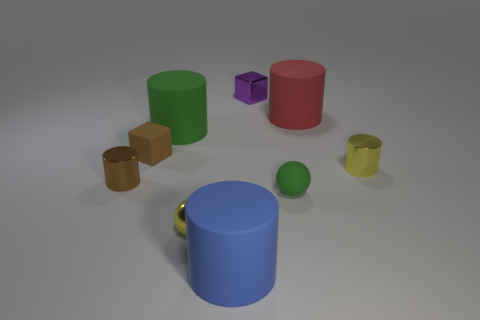There is a large matte cylinder that is in front of the small green ball; is it the same color as the big thing right of the small purple cube?
Give a very brief answer. No. What is the material of the object that is both in front of the small rubber cube and to the left of the big green cylinder?
Make the answer very short. Metal. Are any cyan shiny blocks visible?
Keep it short and to the point. No. The small brown object that is the same material as the red cylinder is what shape?
Make the answer very short. Cube. Do the tiny green rubber object and the yellow metal object on the right side of the large red object have the same shape?
Your answer should be very brief. No. There is a yellow thing that is left of the large rubber cylinder that is on the right side of the purple block; what is it made of?
Your response must be concise. Metal. What number of other things are there of the same shape as the large red matte thing?
Your answer should be very brief. 4. There is a yellow object on the right side of the big blue thing; does it have the same shape as the tiny yellow object left of the blue thing?
Provide a short and direct response. No. Is there any other thing that is made of the same material as the large blue object?
Your response must be concise. Yes. What is the material of the small yellow ball?
Your answer should be compact. Metal. 